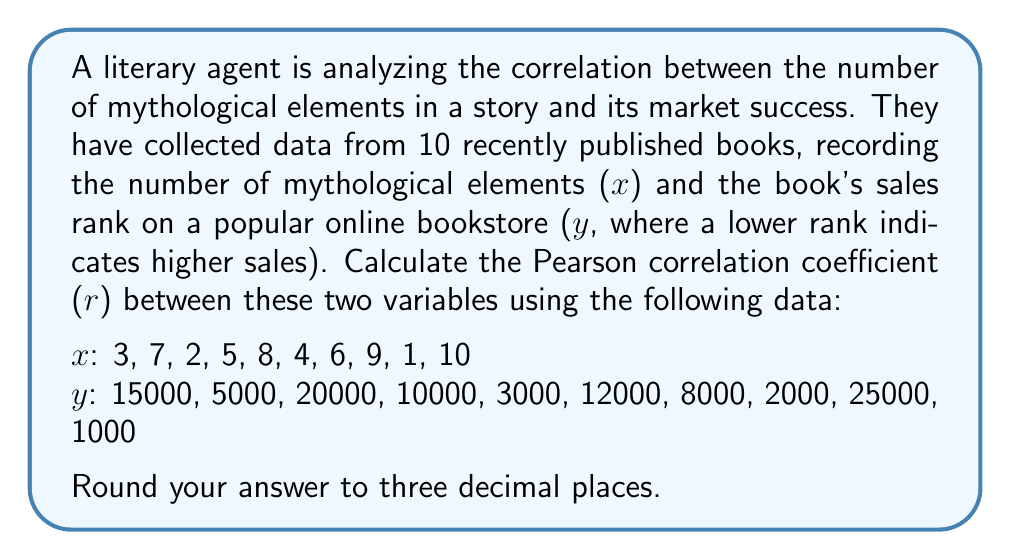Can you answer this question? To calculate the Pearson correlation coefficient (r), we'll use the formula:

$$ r = \frac{n\sum xy - (\sum x)(\sum y)}{\sqrt{[n\sum x^2 - (\sum x)^2][n\sum y^2 - (\sum y)^2]}} $$

where n is the number of data points.

Step 1: Calculate the sums and squared sums:
$\sum x = 55$
$\sum y = 101000$
$\sum x^2 = 385$
$\sum y^2 = 1,741,000,000$
$\sum xy = 431,000$

Step 2: Calculate $n\sum xy$:
$n\sum xy = 10 \times 431,000 = 4,310,000$

Step 3: Calculate $(\sum x)(\sum y)$:
$(\sum x)(\sum y) = 55 \times 101,000 = 5,555,000$

Step 4: Calculate the numerator:
$n\sum xy - (\sum x)(\sum y) = 4,310,000 - 5,555,000 = -1,245,000$

Step 5: Calculate the parts of the denominator:
$n\sum x^2 - (\sum x)^2 = 10 \times 385 - 55^2 = 3,850 - 3,025 = 825$
$n\sum y^2 - (\sum y)^2 = 10 \times 1,741,000,000 - 101,000^2 = 17,410,000,000 - 10,201,000,000 = 7,209,000,000$

Step 6: Calculate the denominator:
$\sqrt{825 \times 7,209,000,000} = 2,438,475.97$

Step 7: Calculate r:
$r = \frac{-1,245,000}{2,438,475.97} = -0.5106$

Step 8: Round to three decimal places:
$r \approx -0.511$
Answer: $r \approx -0.511$ 